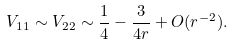Convert formula to latex. <formula><loc_0><loc_0><loc_500><loc_500>V _ { 1 1 } \sim V _ { 2 2 } \sim \frac { 1 } { 4 } - \frac { 3 } { 4 r } + O ( r ^ { - 2 } ) .</formula> 